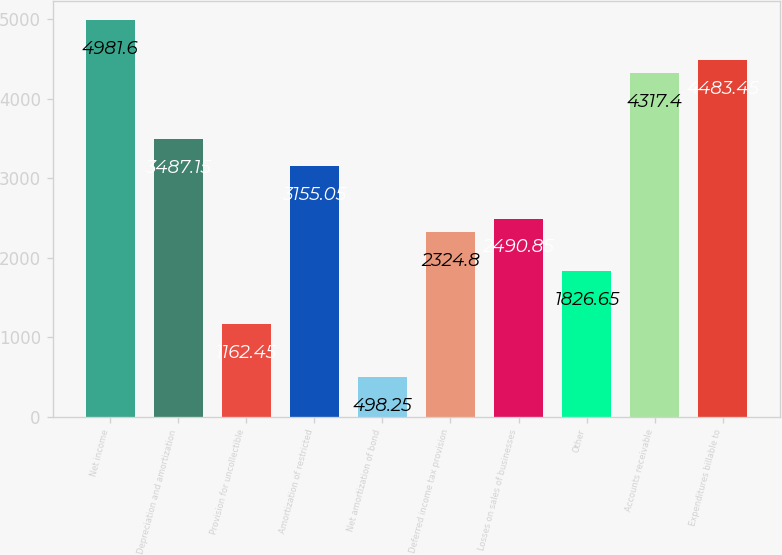<chart> <loc_0><loc_0><loc_500><loc_500><bar_chart><fcel>Net income<fcel>Depreciation and amortization<fcel>Provision for uncollectible<fcel>Amortization of restricted<fcel>Net amortization of bond<fcel>Deferred income tax provision<fcel>Losses on sales of businesses<fcel>Other<fcel>Accounts receivable<fcel>Expenditures billable to<nl><fcel>4981.6<fcel>3487.15<fcel>1162.45<fcel>3155.05<fcel>498.25<fcel>2324.8<fcel>2490.85<fcel>1826.65<fcel>4317.4<fcel>4483.45<nl></chart> 